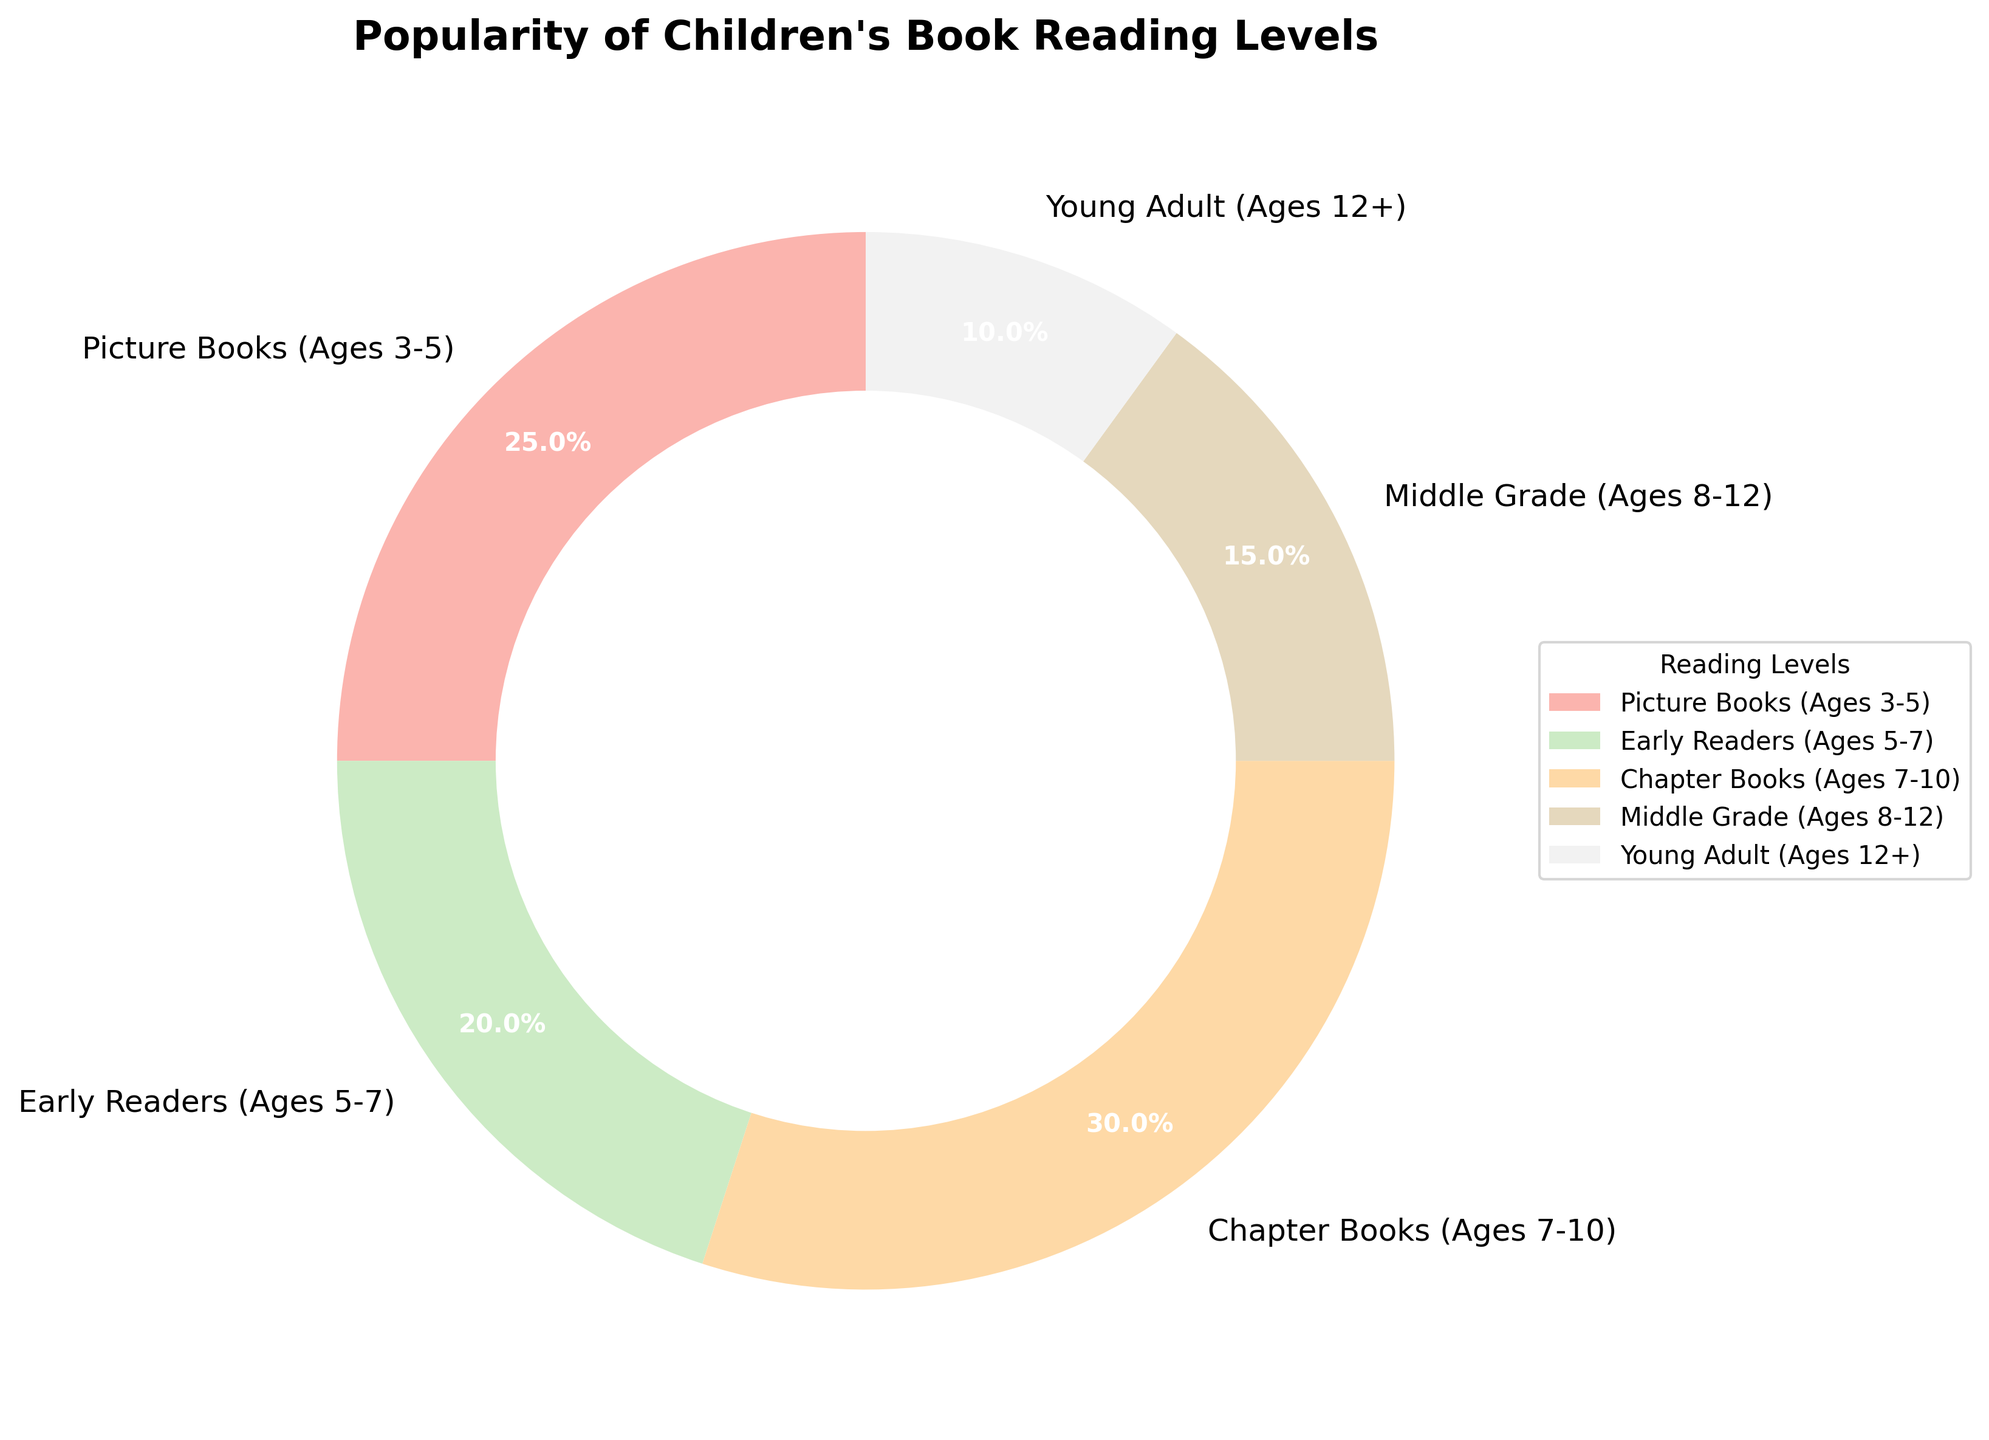What's the most popular reading level for children's books? The largest wedge in the pie chart represents Chapter Books (Ages 7-10), which has the highest percentage of 30%.
Answer: Chapter Books (Ages 7-10) Which reading level is least popular? The smallest wedge in the pie chart represents Young Adult (Ages 12+), showing the lowest percentage of 10%.
Answer: Young Adult (Ages 12+) How much more popular are Chapter Books (Ages 7-10) compared to Middle Grade (Ages 8-12)? Chapter Books account for 30%, while Middle Grade accounts for 15%. The difference is calculated as 30% - 15% = 15%.
Answer: 15% What is the sum of the percentages for Picture Books and Early Readers? Picture Books account for 25% and Early Readers for 20%, giving a sum of 25% + 20% = 45%.
Answer: 45% Which reading levels together make up half of the popularity? Picture Books and Chapter Books together equal 25% + 30% = 55%, which is more than half. If we consider Picture Books (25%) and Early Readers (20%), the sum is 45%, so they don’t meet the criteria. Thus, no exact combination adds up to exactly half.
Answer: None Is the percentage of Early Readers higher or lower than the percentage of Middle Grade? Early Readers have a percentage of 20%, while Middle Grade has a percentage of 15%. Comparing these values, Early Readers are higher.
Answer: Higher How much more popular are Picture Books compared to Young Adult Books? Picture Books have a percentage of 25% and Young Adult Books have 10%. The difference is 25% - 10% = 15%.
Answer: 15% What is the combined percentage of books suitable for children aged 7-10 and 8-12? Chapter Books (Ages 7-10) make up 30% and Middle Grade (Ages 8-12) make up 15%. The combined percentage is 30% + 15% = 45%.
Answer: 45% Which two reading levels have nearly equal percentages? Early Readers at 20% and Middle Grade at 15% have the closest percentages, differing by only 5%.
Answer: Early Readers and Middle Grade 